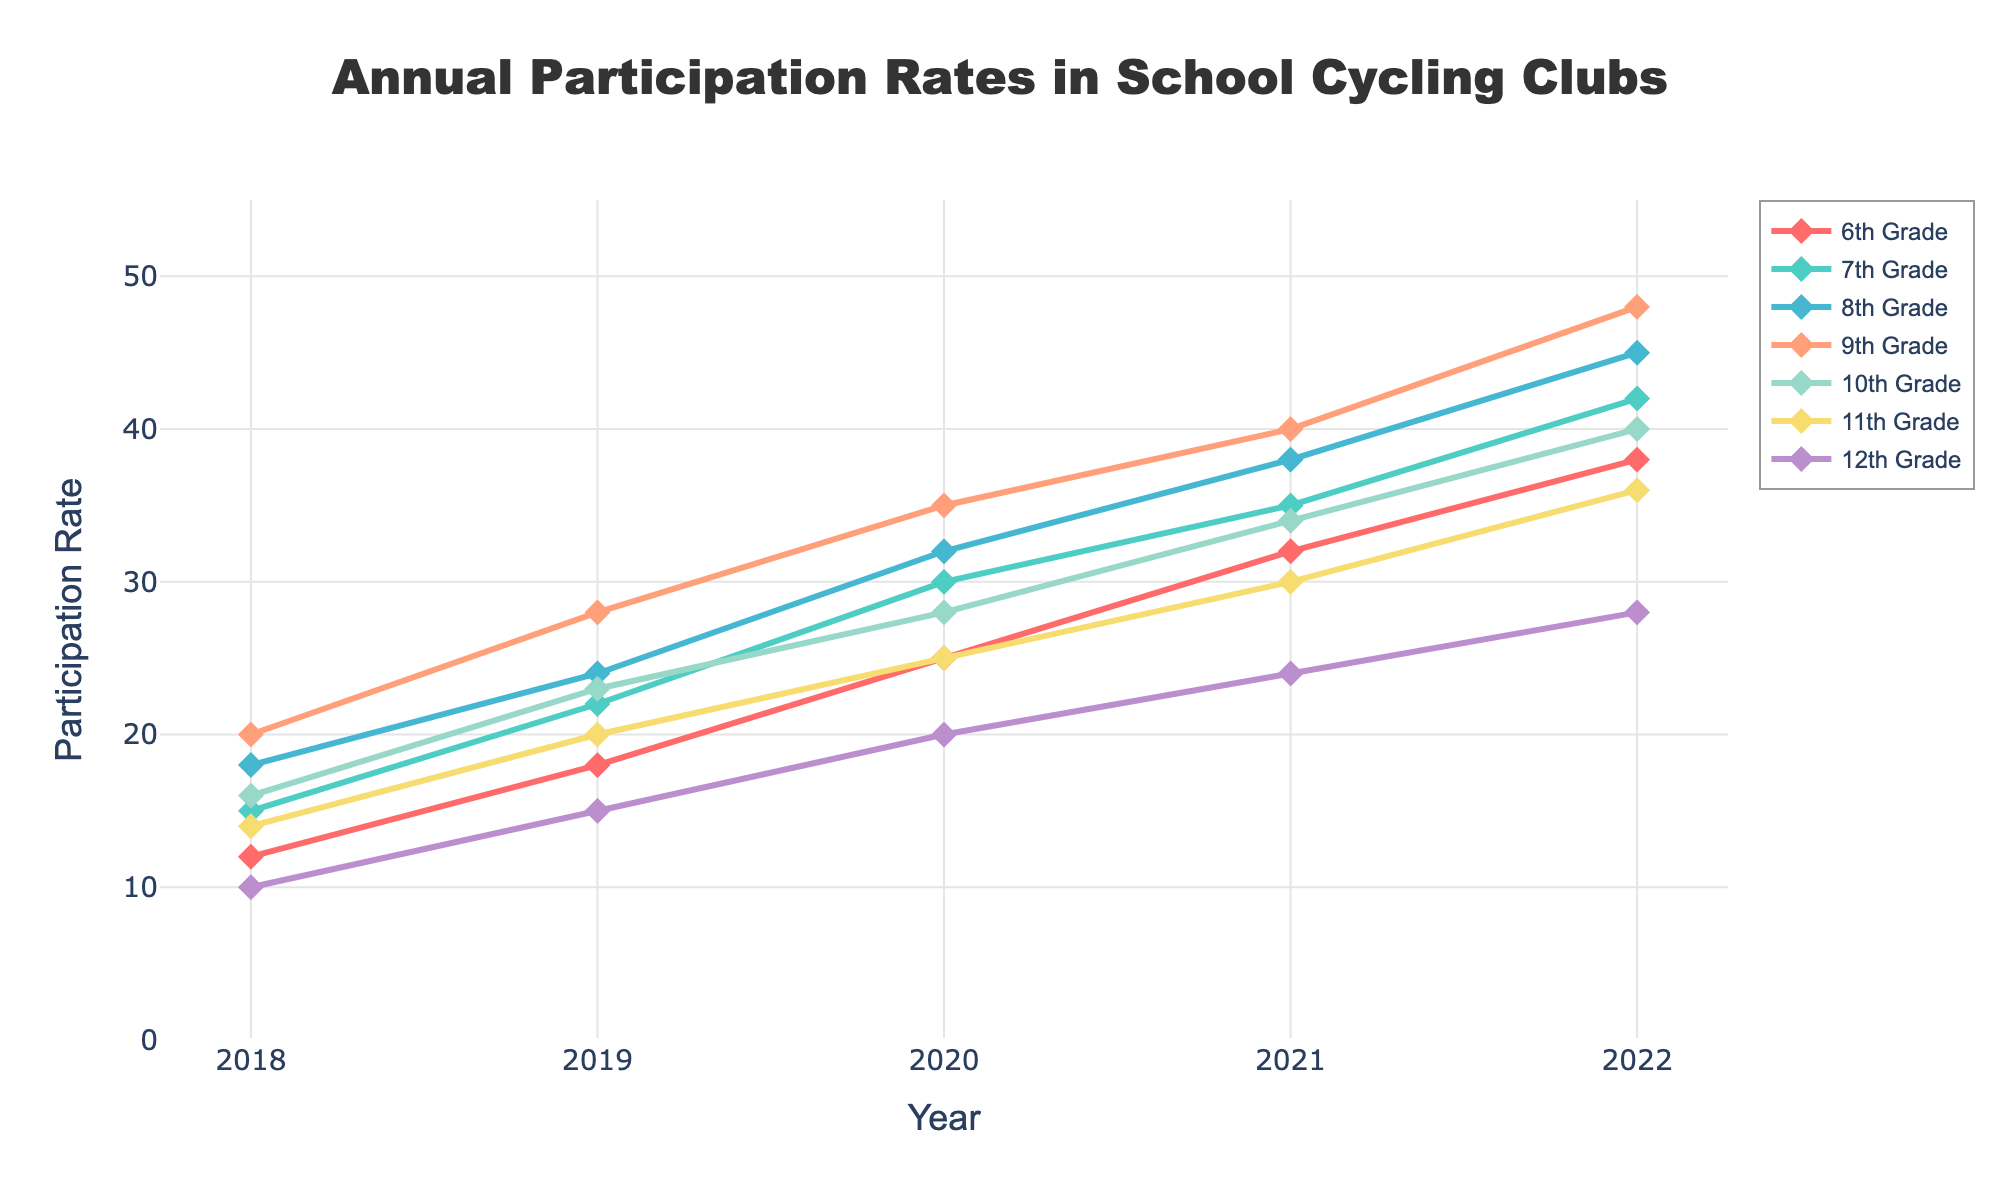What is the trend of participation rates in the 9th Grade from 2018 to 2022? From the figure, find the points for the 9th Grade and observe their changes over the years. The participation rate increases each year: 20 in 2018, 28 in 2019, 35 in 2020, 40 in 2021, and 48 in 2022.
Answer: Increasing trend Which grade had the highest participation rate in 2022? In the figure, locate the year 2022 and compare the participation rates for each grade. The 9th Grade has the highest participation rate with 48 participants.
Answer: 9th Grade Did the participation rate for the 12th Grade ever surpass 25 in any year? Look for the line representing the 12th Grade and check its value each year. In 2021, the participation rate is 24 and in 2022 it reaches 28, thus surpassing 25 in 2022.
Answer: Yes, in 2022 What is the difference in participation rates between the 7th Grade and the 12th Grade in 2022? Find the participation rates for the 7th Grade and the 12th Grade in 2022. The 7th Grade has 42 participants and the 12th Grade has 28. The difference is 42 - 28.
Answer: 14 Which grade consistently had the lowest participation rate from 2018 to 2022? Compare the lines for each grade across all years to see which one stays the lowest. The 12th Grade consistently has the lowest participation rates in all years.
Answer: 12th Grade What is the average participation rate in 10th Grade across all years? For the 10th Grade, sum up the participation rates (16 + 23 + 28 + 34 + 40) and divide by the number of years (5). The total is 141, so the average is 141 / 5.
Answer: 28.2 By how much did the participation rate for the 8th Grade increase from 2018 to 2022? Identify the participation rates for the 8th Grade in 2018 (18) and in 2022 (45). The increase is 45 - 18.
Answer: 27 What is the color of the line that represents the 6th Grade? Look at the visual representation of the 6th Grade in the line chart. The line color for the 6th Grade is red.
Answer: Red Are there any grades whose participation rates decrease in any single year? Check the lines for each grade to see if there are any declines over the years. All grades have an upward or equal trend; none show a decrease in any year.
Answer: No Which grade had the closest participation rates to each other in 2021? In 2021, compare the participation rates for all grades. The 12th Grade and the 10th Grade have the rates 24 and 34 respectively, with the smallest difference.
Answer: 10th and 12th Grade 